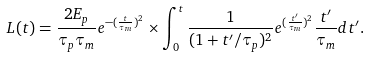Convert formula to latex. <formula><loc_0><loc_0><loc_500><loc_500>L ( t ) = \frac { 2 E _ { p } } { \tau _ { p } \tau _ { m } } e ^ { - ( \frac { t } { \tau _ { m } } ) ^ { 2 } } \times \int _ { 0 } ^ { t } \frac { 1 } { ( 1 + t ^ { \prime } / \tau _ { p } ) ^ { 2 } } e ^ { ( \frac { t ^ { \prime } } { \tau _ { m } } ) ^ { 2 } } \frac { t ^ { \prime } } { \tau _ { m } } d t ^ { \prime } .</formula> 